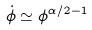<formula> <loc_0><loc_0><loc_500><loc_500>\dot { \phi } \simeq \phi ^ { \alpha / 2 - 1 }</formula> 